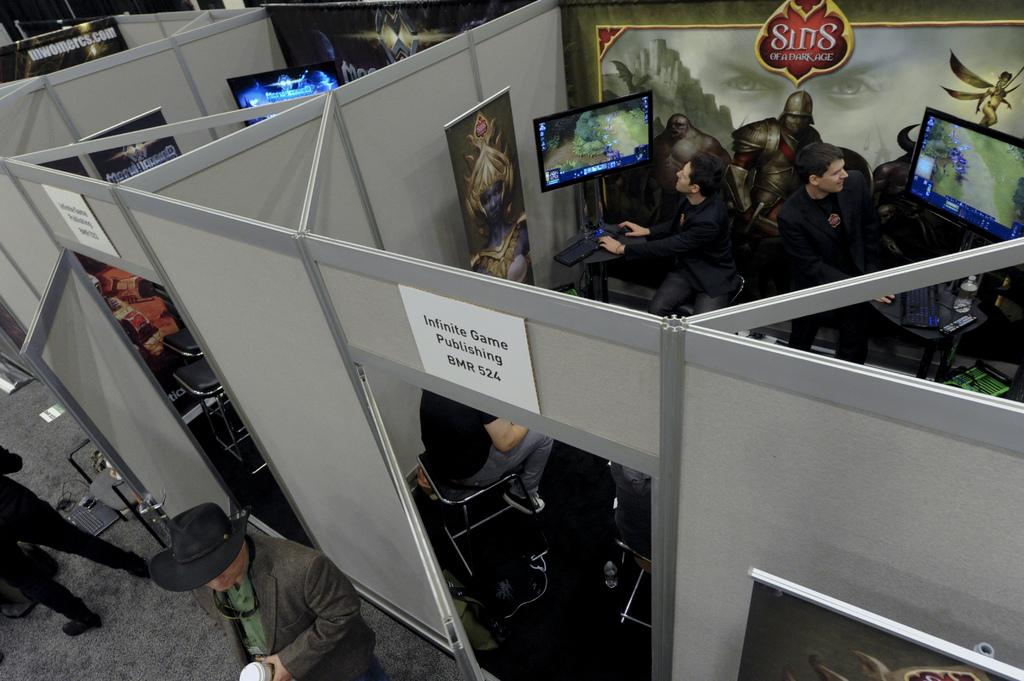<image>
Offer a succinct explanation of the picture presented. People play a video game called Sins of a Dark Age. 